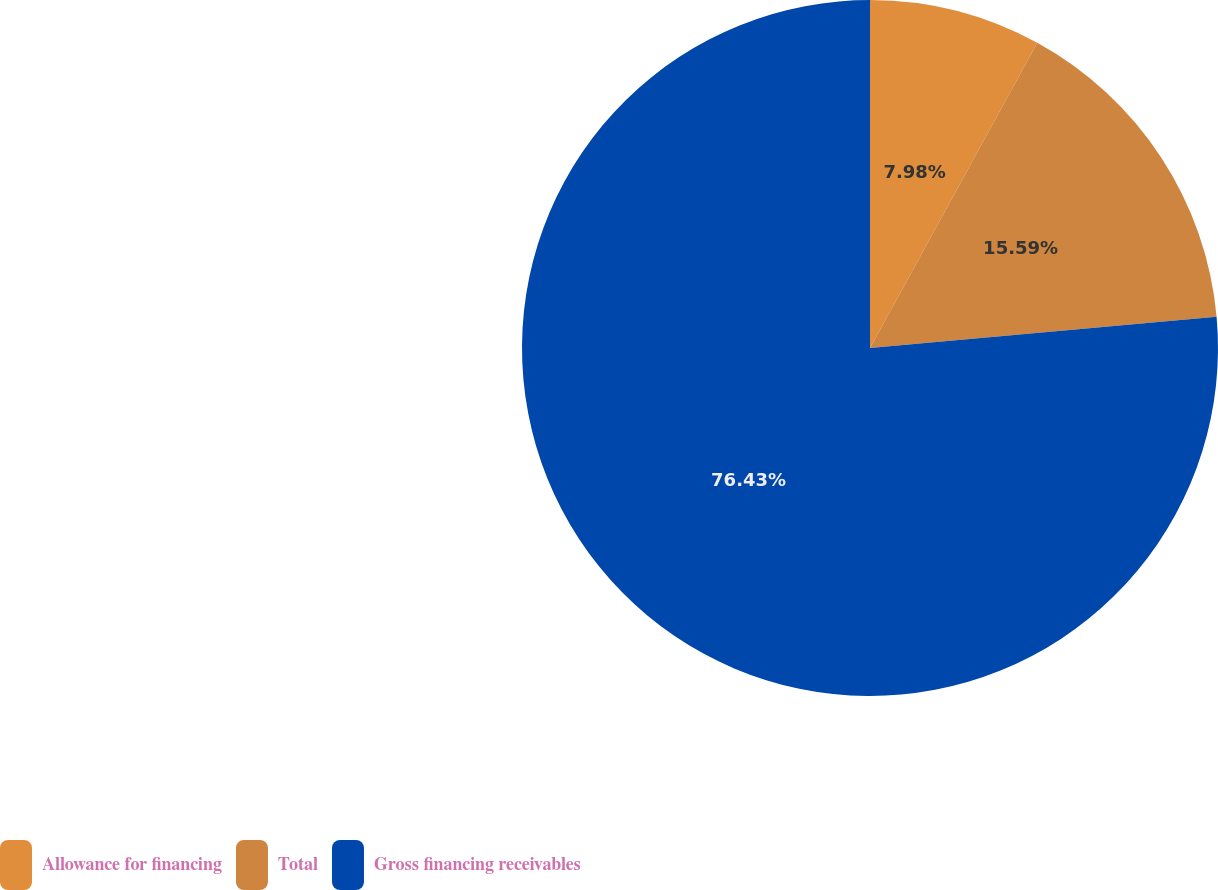Convert chart to OTSL. <chart><loc_0><loc_0><loc_500><loc_500><pie_chart><fcel>Allowance for financing<fcel>Total<fcel>Gross financing receivables<nl><fcel>7.98%<fcel>15.59%<fcel>76.43%<nl></chart> 